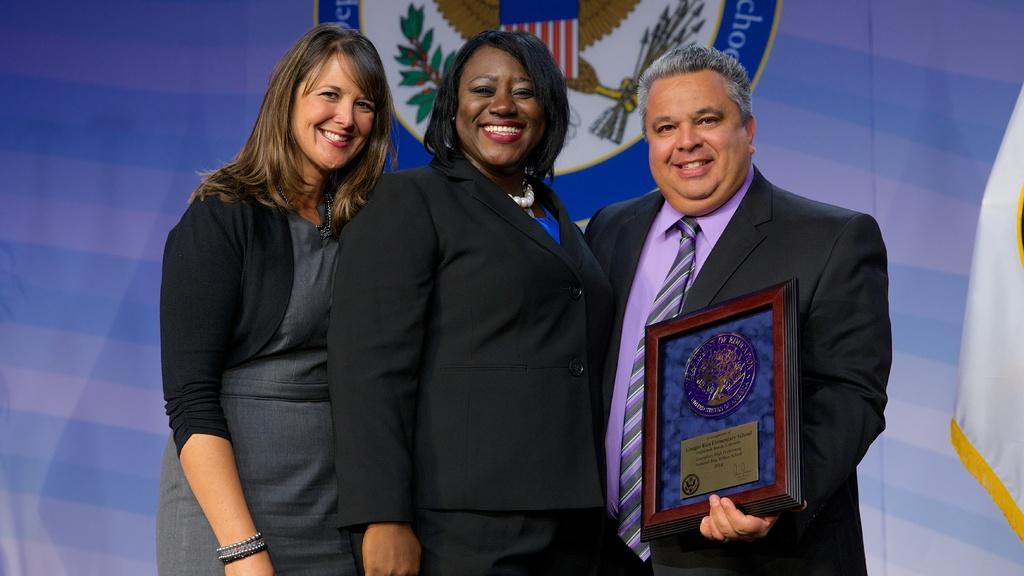How would you summarize this image in a sentence or two? In the image i can see three people are standing and smiling. In the background i can see some text is written. 